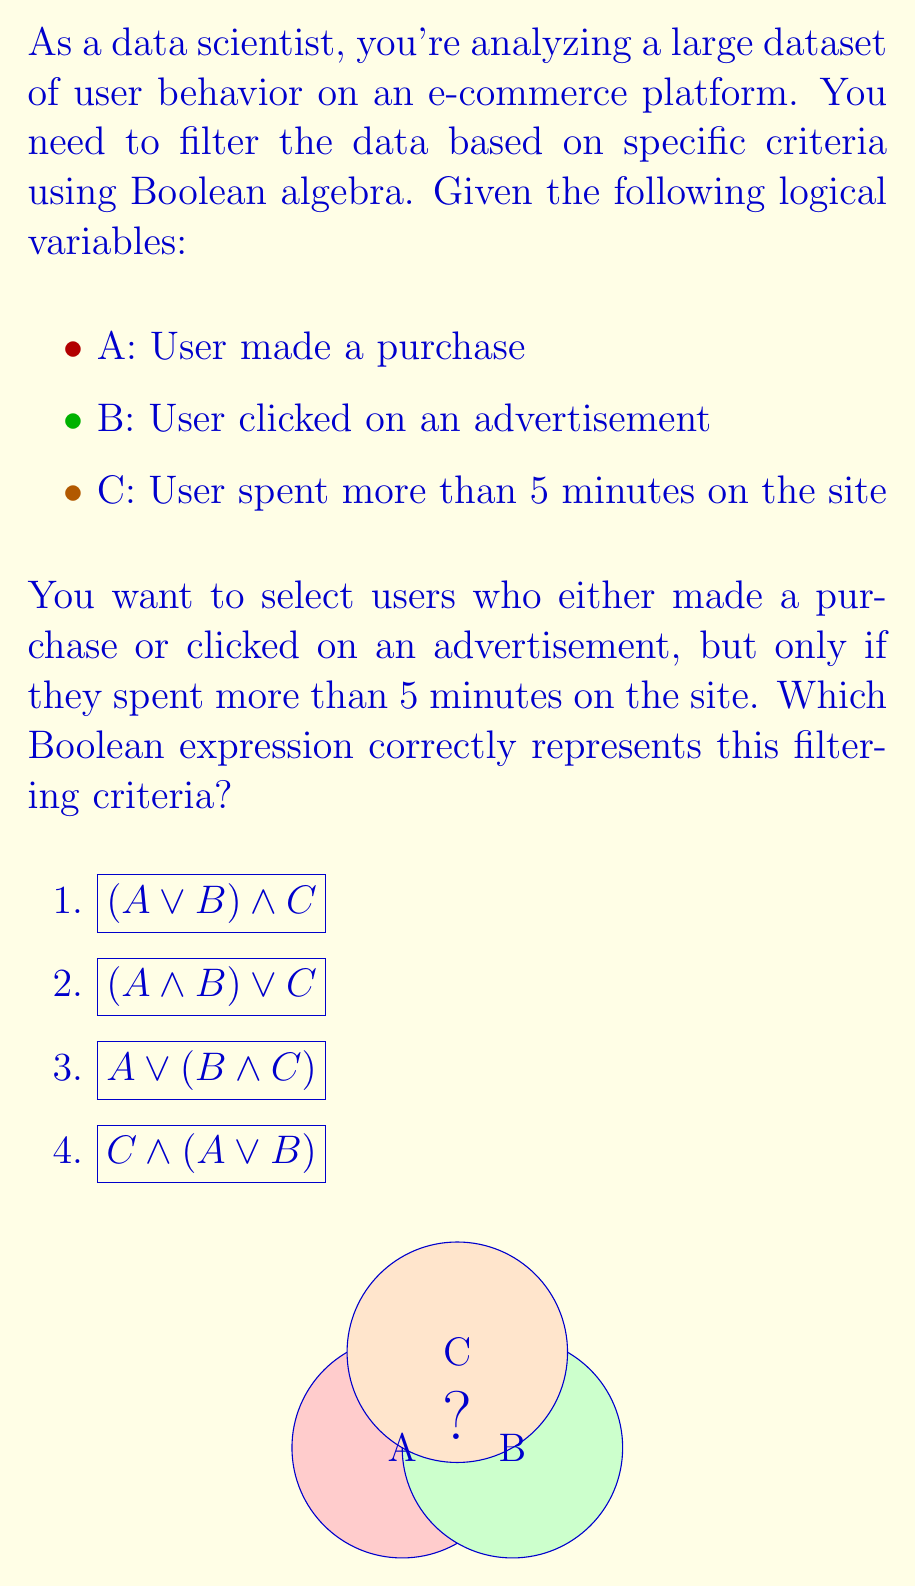Can you solve this math problem? Let's break down the problem and analyze each option step-by-step:

1) First, we need to understand the filtering criteria:
   - We want users who made a purchase OR clicked on an advertisement
   - AND these users must have spent more than 5 minutes on the site

2) Let's translate this into Boolean algebra:
   - (A OR B) represents users who made a purchase or clicked on an ad
   - This needs to be combined with C (spent more than 5 minutes) using AND

3) Analyzing the options:

   a) $$(A \lor B) \land C$$
      This correctly represents our criteria. It selects users who (made a purchase OR clicked an ad) AND spent more than 5 minutes.

   b) $$(A \land B) \lor C$$
      This would select users who (made a purchase AND clicked an ad) OR spent more than 5 minutes. This doesn't match our criteria.

   c) $$A \lor (B \land C)$$
      This selects users who made a purchase OR (clicked an ad AND spent more than 5 minutes). This doesn't capture all cases we want.

   d) $$C \land (A \lor B)$$
      This is equivalent to option 1, just written in a different order. It correctly represents our criteria.

4) The Venn diagram in the question visually represents the intersection of sets A, B, and C. The correct answer should include the overlapping region of C with either A or B, or both.

5) Therefore, both options 1 and 4 correctly represent the filtering criteria we need.
Answer: $$(A \lor B) \land C$$ or $$C \land (A \lor B)$$ 